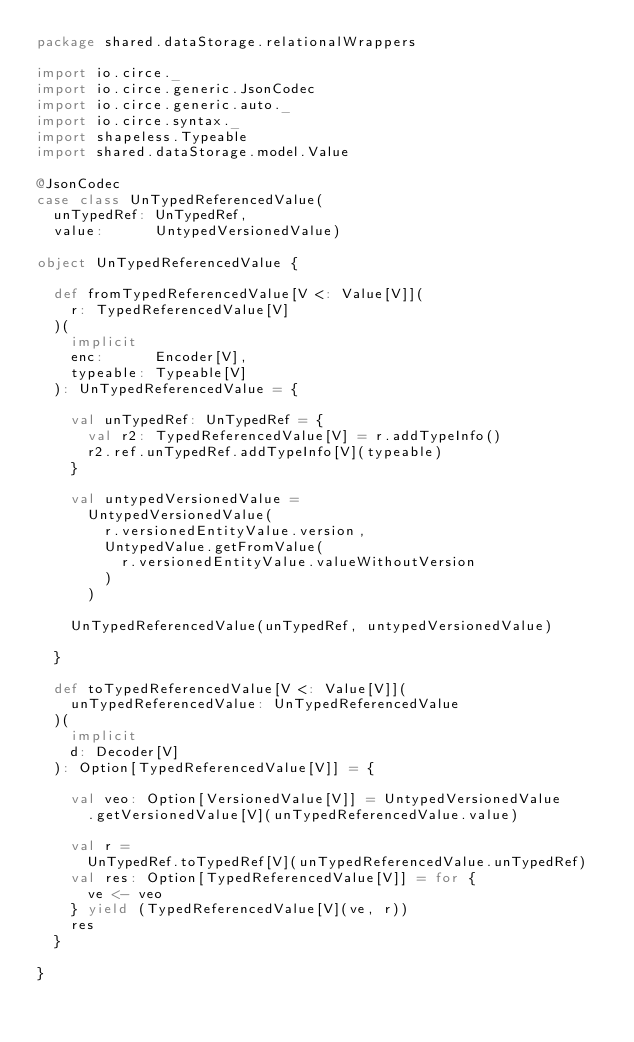Convert code to text. <code><loc_0><loc_0><loc_500><loc_500><_Scala_>package shared.dataStorage.relationalWrappers

import io.circe._
import io.circe.generic.JsonCodec
import io.circe.generic.auto._
import io.circe.syntax._
import shapeless.Typeable
import shared.dataStorage.model.Value

@JsonCodec
case class UnTypedReferencedValue(
  unTypedRef: UnTypedRef,
  value:      UntypedVersionedValue)

object UnTypedReferencedValue {

  def fromTypedReferencedValue[V <: Value[V]](
    r: TypedReferencedValue[V]
  )(
    implicit
    enc:      Encoder[V],
    typeable: Typeable[V]
  ): UnTypedReferencedValue = {

    val unTypedRef: UnTypedRef = {
      val r2: TypedReferencedValue[V] = r.addTypeInfo()
      r2.ref.unTypedRef.addTypeInfo[V](typeable)
    }

    val untypedVersionedValue =
      UntypedVersionedValue(
        r.versionedEntityValue.version,
        UntypedValue.getFromValue(
          r.versionedEntityValue.valueWithoutVersion
        )
      )

    UnTypedReferencedValue(unTypedRef, untypedVersionedValue)

  }

  def toTypedReferencedValue[V <: Value[V]](
    unTypedReferencedValue: UnTypedReferencedValue
  )(
    implicit
    d: Decoder[V]
  ): Option[TypedReferencedValue[V]] = {

    val veo: Option[VersionedValue[V]] = UntypedVersionedValue
      .getVersionedValue[V](unTypedReferencedValue.value)

    val r =
      UnTypedRef.toTypedRef[V](unTypedReferencedValue.unTypedRef)
    val res: Option[TypedReferencedValue[V]] = for {
      ve <- veo
    } yield (TypedReferencedValue[V](ve, r))
    res
  }

}
</code> 